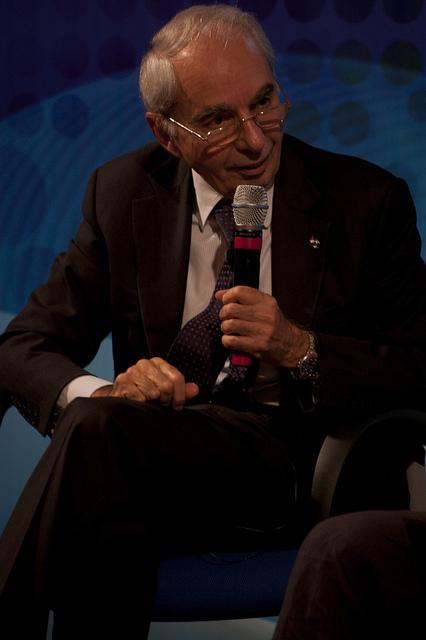How might many who listen to this speaker hear his message? speakers 